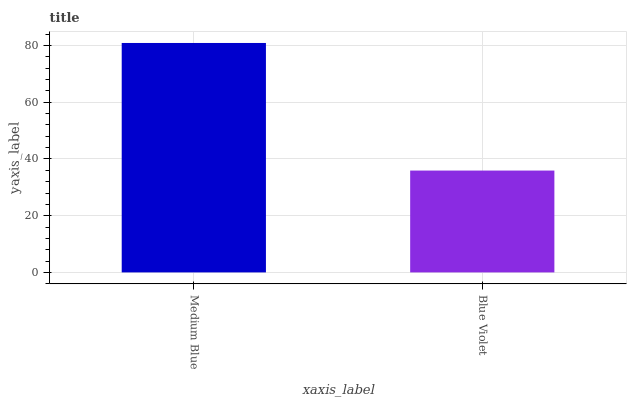Is Blue Violet the minimum?
Answer yes or no. Yes. Is Medium Blue the maximum?
Answer yes or no. Yes. Is Blue Violet the maximum?
Answer yes or no. No. Is Medium Blue greater than Blue Violet?
Answer yes or no. Yes. Is Blue Violet less than Medium Blue?
Answer yes or no. Yes. Is Blue Violet greater than Medium Blue?
Answer yes or no. No. Is Medium Blue less than Blue Violet?
Answer yes or no. No. Is Medium Blue the high median?
Answer yes or no. Yes. Is Blue Violet the low median?
Answer yes or no. Yes. Is Blue Violet the high median?
Answer yes or no. No. Is Medium Blue the low median?
Answer yes or no. No. 